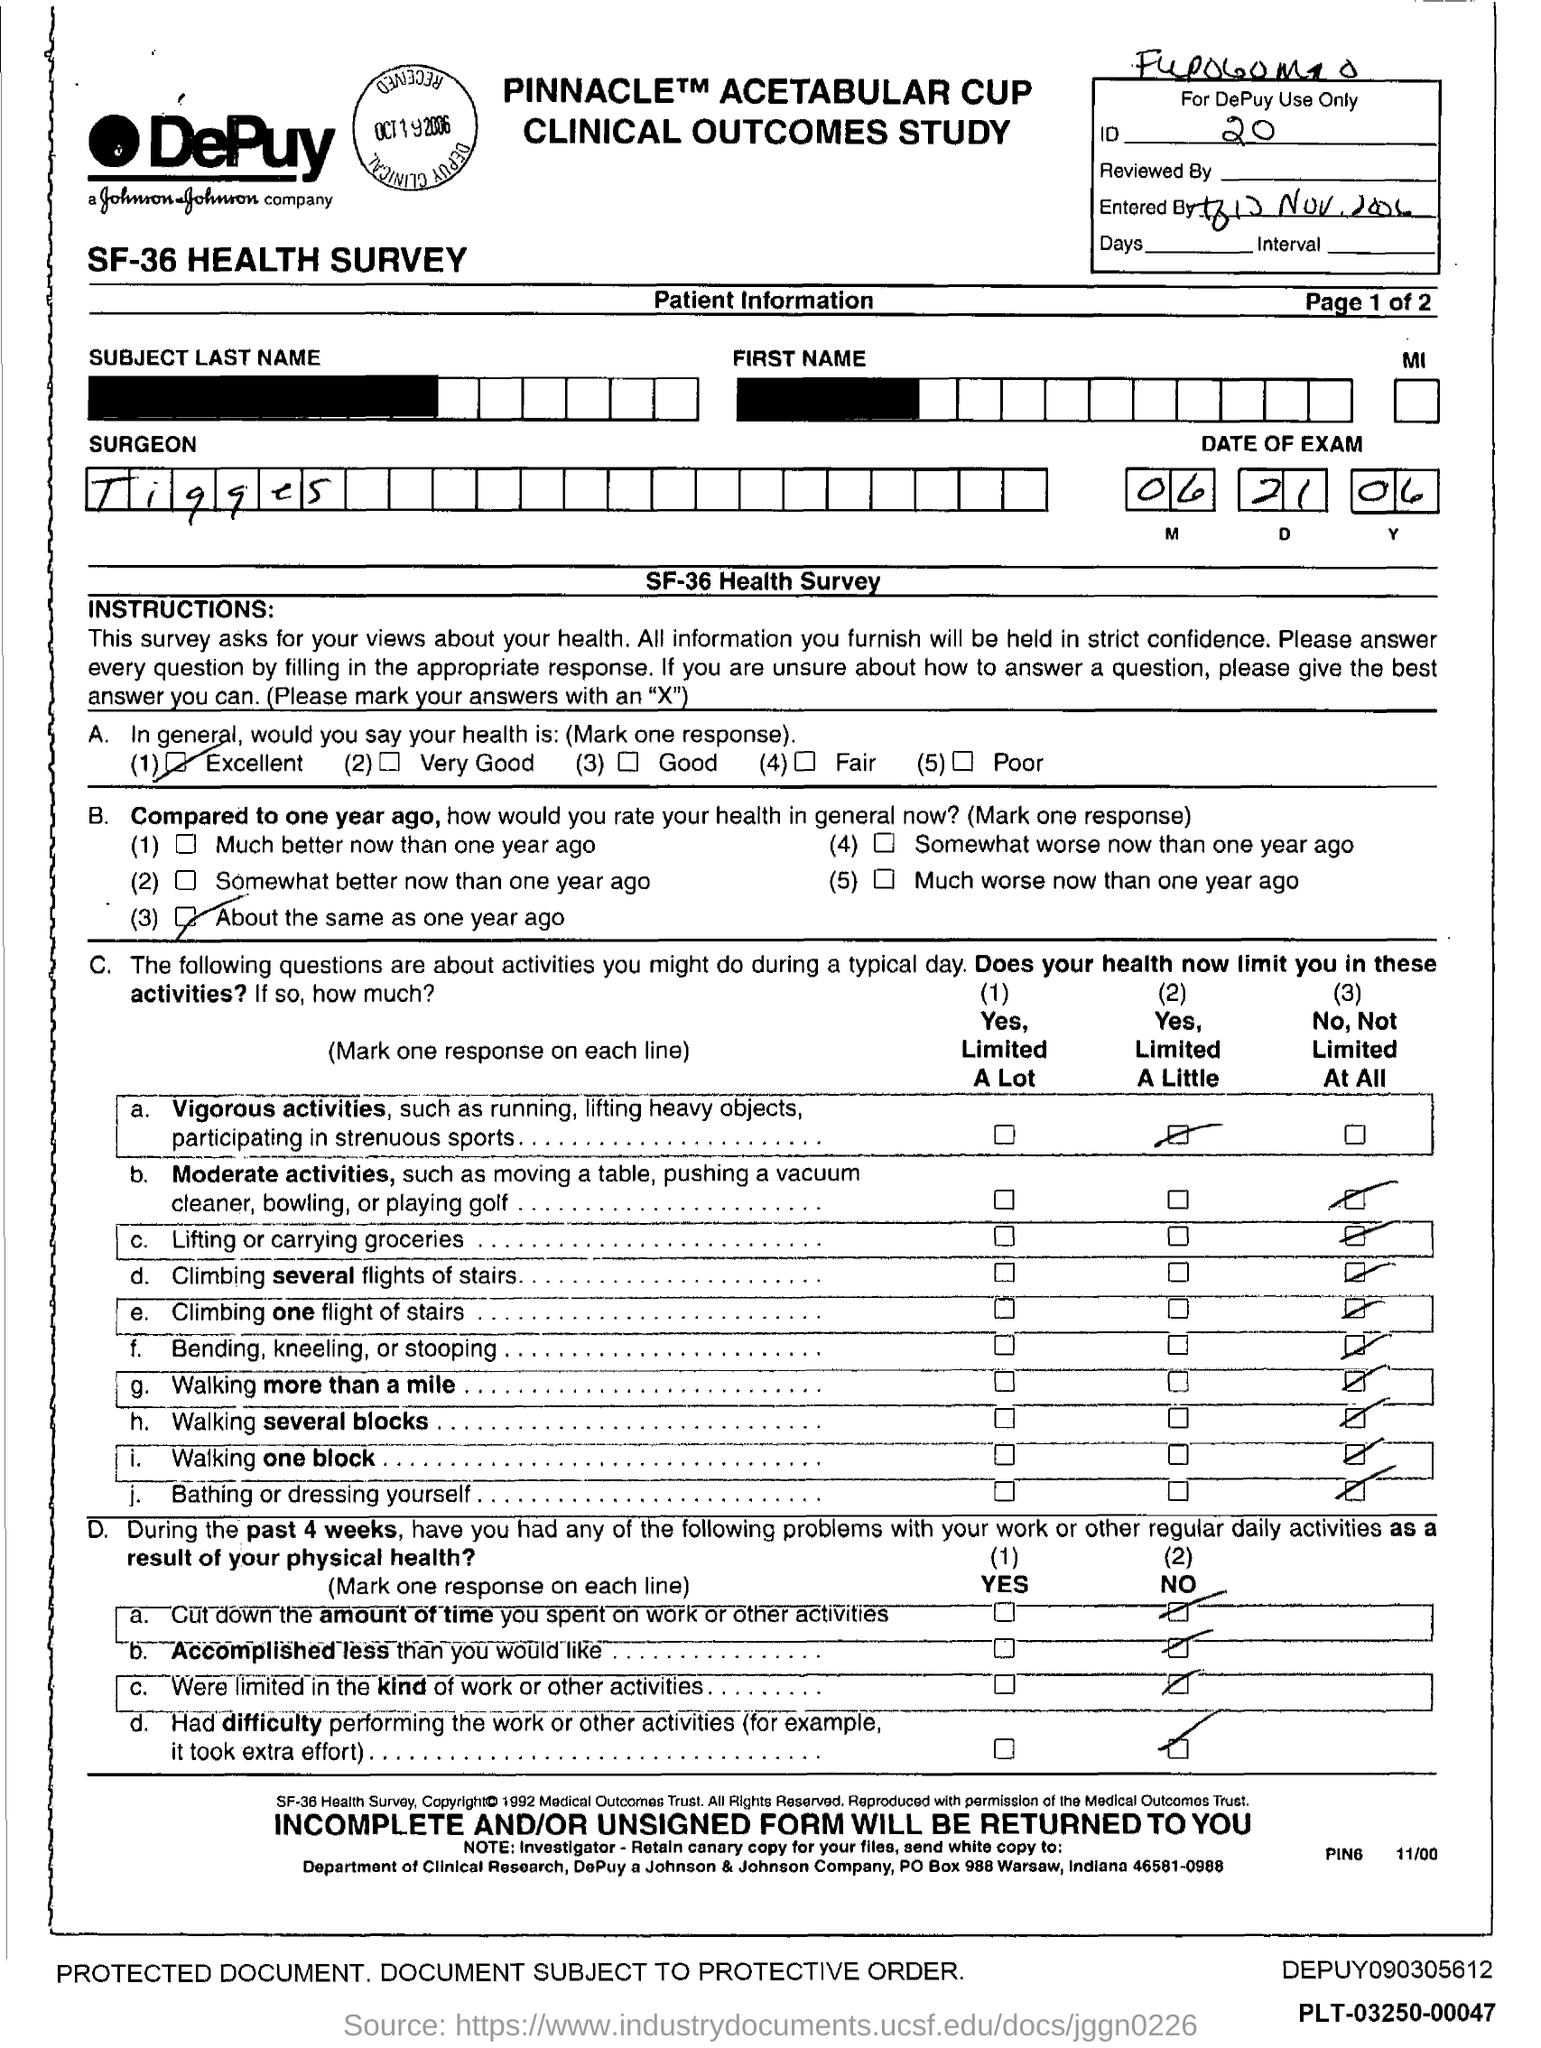What is the ID mentioned in the form?
Offer a terse response. 20. What is the date of exam given in the form?
Provide a short and direct response. 06.21.06. What is the surgeon name mentioned in the form?
Your answer should be very brief. Tigges. 